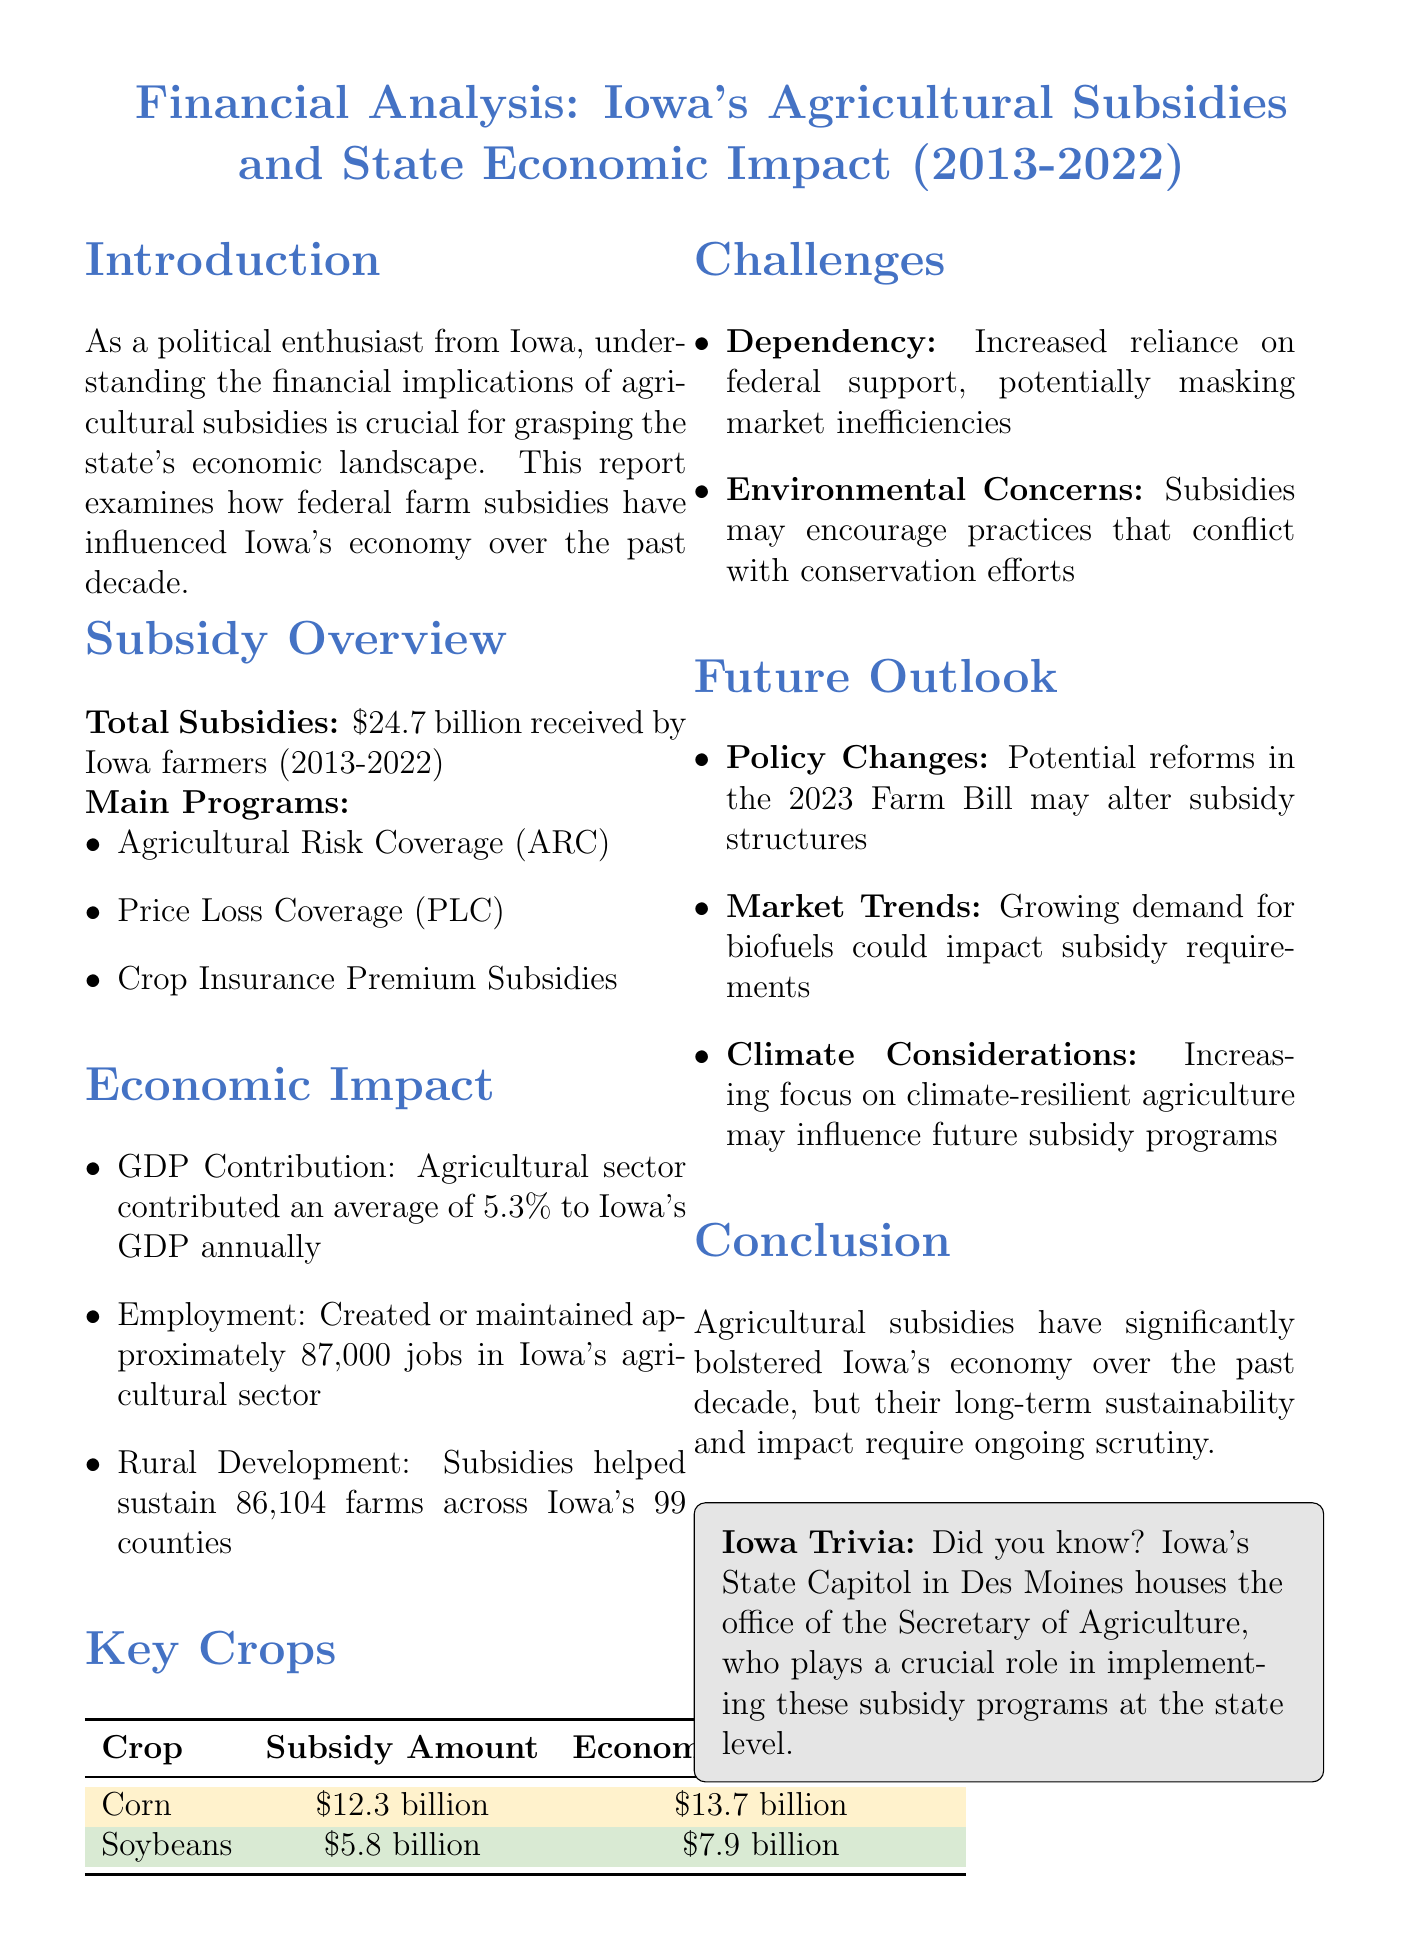What is the total amount of agricultural subsidies received by Iowa farmers from 2013 to 2022? The document states that Iowa farmers received a total of $24.7 billion in agricultural subsidies during this period.
Answer: $24.7 billion How many jobs were created or maintained in Iowa's agricultural sector due to subsidies? According to the report, approximately 87,000 jobs were created or maintained in the agricultural sector due to subsidies.
Answer: 87,000 What are the two main crops discussed in the report? The document highlights corn and soybeans as the two main crops affected by agricultural subsidies.
Answer: Corn and soybeans What percentage did the agricultural sector contribute to Iowa's GDP annually? The report indicates that the agricultural sector contributed an average of 5.3% to Iowa's GDP annually.
Answer: 5.3% What potential reform may affect subsidy structures in the future? The document mentions that potential reforms in the 2023 Farm Bill may alter subsidy structures.
Answer: 2023 Farm Bill What environmental concern is raised regarding agricultural subsidies? The report discusses that subsidies may encourage practices that conflict with conservation efforts, highlighting environmental concerns.
Answer: Environmental concerns What was the economic value of corn in 2022? The report lists the economic value of corn as $13.7 billion in 2022.
Answer: $13.7 billion How many farms were sustained due to subsidies across Iowa's counties? The document states that subsidies helped sustain 86,104 farms across Iowa's 99 counties.
Answer: 86,104 farms 